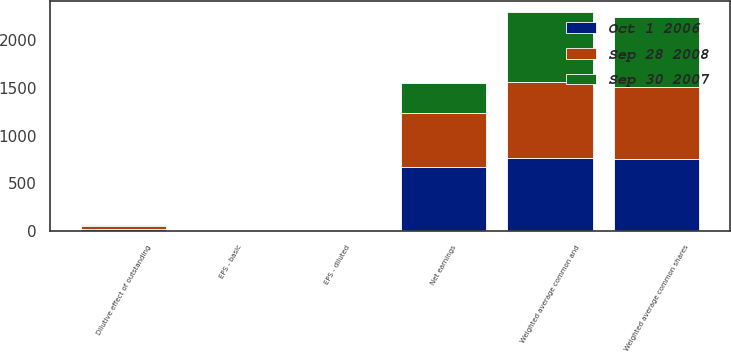Convert chart. <chart><loc_0><loc_0><loc_500><loc_500><stacked_bar_chart><ecel><fcel>Net earnings<fcel>Weighted average common shares<fcel>Dilutive effect of outstanding<fcel>Weighted average common and<fcel>EPS - basic<fcel>EPS - diluted<nl><fcel>Sep 30 2007<fcel>315.5<fcel>731.5<fcel>10.2<fcel>741.7<fcel>0.43<fcel>0.43<nl><fcel>Oct 1 2006<fcel>672.6<fcel>749.8<fcel>20.3<fcel>770.1<fcel>0.9<fcel>0.87<nl><fcel>Sep 28 2008<fcel>564.3<fcel>766.1<fcel>26.5<fcel>792.6<fcel>0.74<fcel>0.71<nl></chart> 